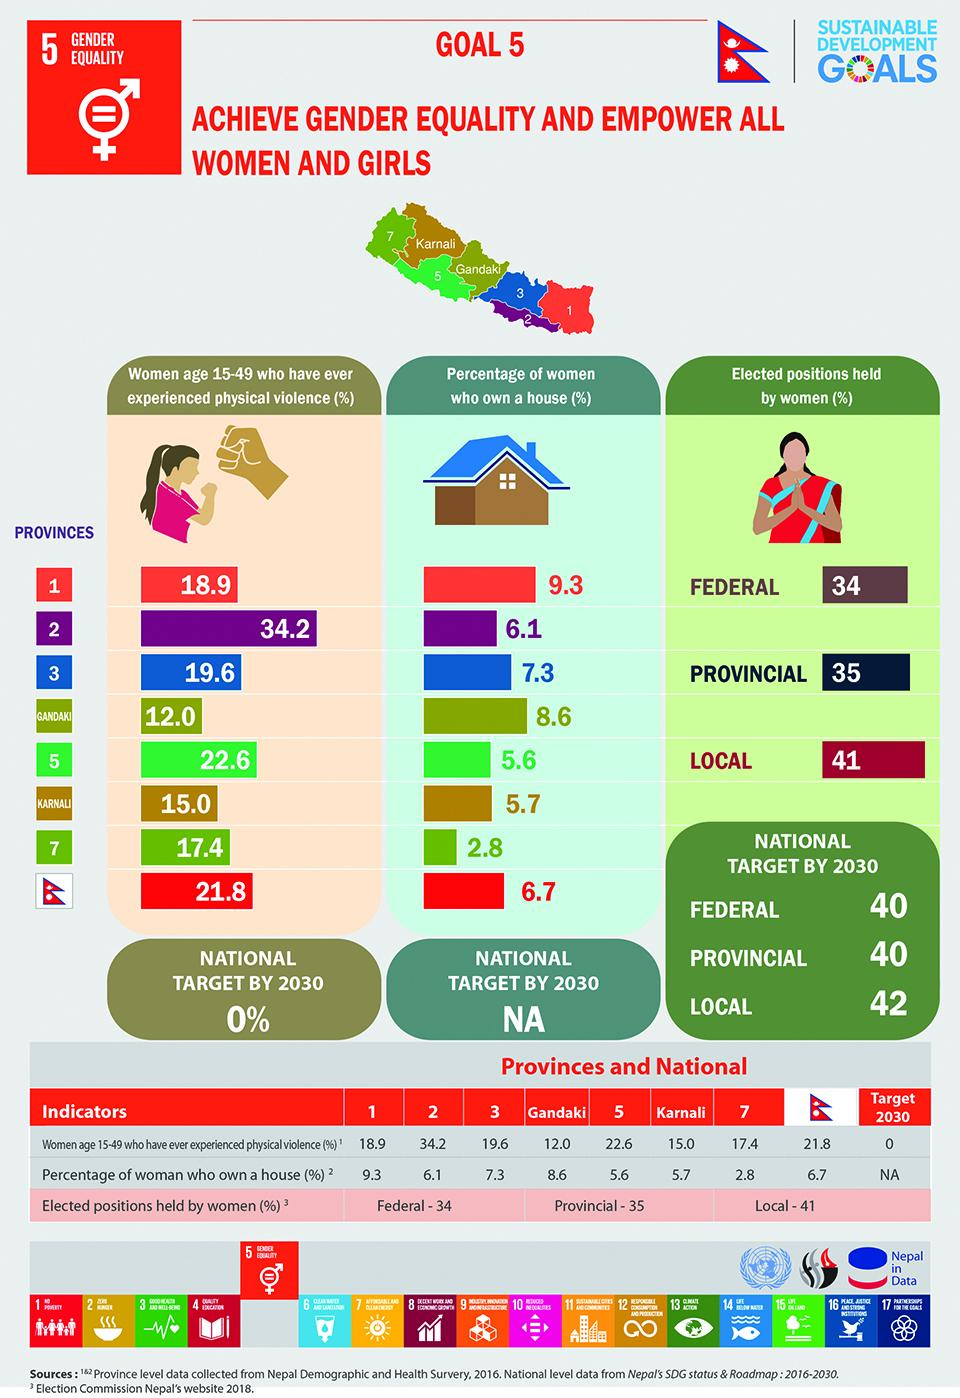Identify some key points in this picture. Gandaki Province has the second highest percentage of women owning a house among all provinces in Nepal. In Karnali Province, a staggering 81% of women have experienced physical violence, making it the second province with the lowest percentage of women who have experienced physical violence. In the province with the lowest level of house ownership, 17.4% of women reported experiencing physical violence. In the second province, the highest percentage of women reported experiencing physical violence. According to the latest statistics, in the province with the highest rate of physical violence against women, only 6.1% of women own their own homes. 